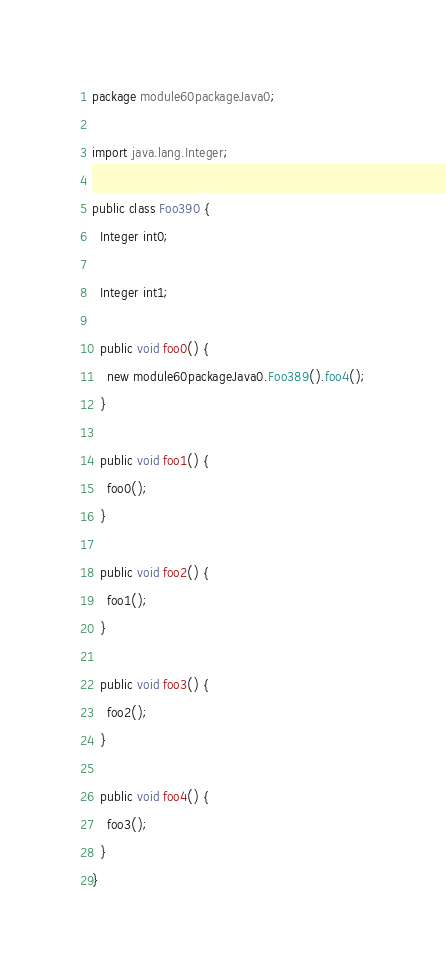Convert code to text. <code><loc_0><loc_0><loc_500><loc_500><_Java_>package module60packageJava0;

import java.lang.Integer;

public class Foo390 {
  Integer int0;

  Integer int1;

  public void foo0() {
    new module60packageJava0.Foo389().foo4();
  }

  public void foo1() {
    foo0();
  }

  public void foo2() {
    foo1();
  }

  public void foo3() {
    foo2();
  }

  public void foo4() {
    foo3();
  }
}
</code> 